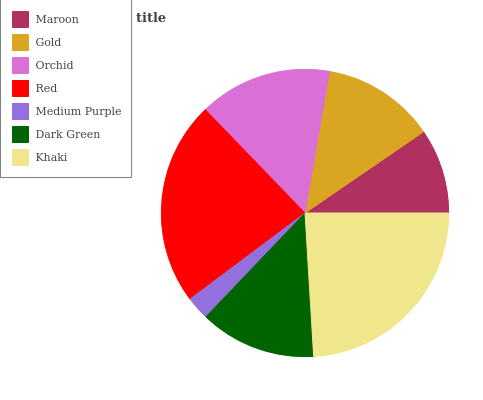Is Medium Purple the minimum?
Answer yes or no. Yes. Is Khaki the maximum?
Answer yes or no. Yes. Is Gold the minimum?
Answer yes or no. No. Is Gold the maximum?
Answer yes or no. No. Is Gold greater than Maroon?
Answer yes or no. Yes. Is Maroon less than Gold?
Answer yes or no. Yes. Is Maroon greater than Gold?
Answer yes or no. No. Is Gold less than Maroon?
Answer yes or no. No. Is Dark Green the high median?
Answer yes or no. Yes. Is Dark Green the low median?
Answer yes or no. Yes. Is Maroon the high median?
Answer yes or no. No. Is Orchid the low median?
Answer yes or no. No. 